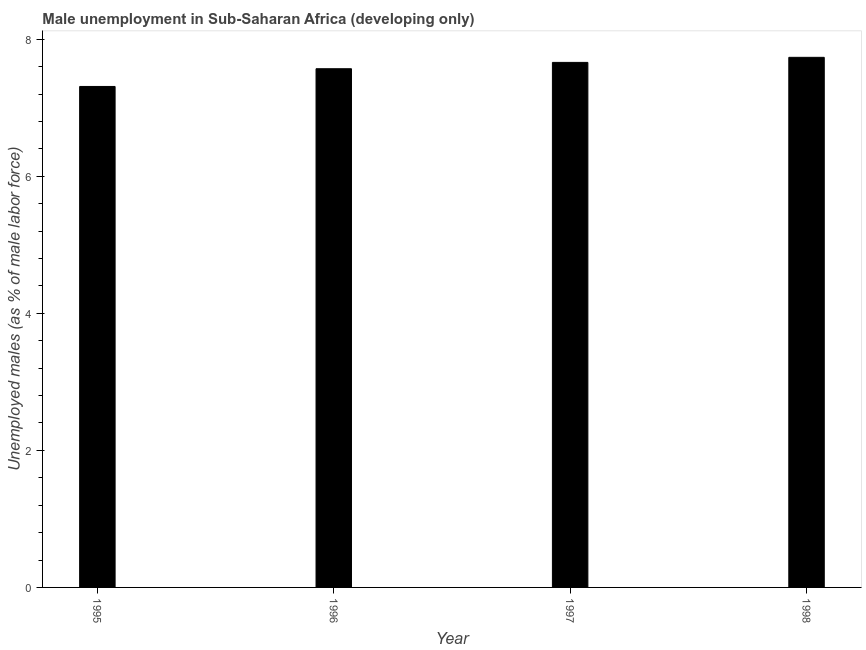What is the title of the graph?
Your answer should be compact. Male unemployment in Sub-Saharan Africa (developing only). What is the label or title of the Y-axis?
Offer a very short reply. Unemployed males (as % of male labor force). What is the unemployed males population in 1998?
Provide a succinct answer. 7.74. Across all years, what is the maximum unemployed males population?
Offer a terse response. 7.74. Across all years, what is the minimum unemployed males population?
Ensure brevity in your answer.  7.31. In which year was the unemployed males population maximum?
Keep it short and to the point. 1998. In which year was the unemployed males population minimum?
Offer a terse response. 1995. What is the sum of the unemployed males population?
Give a very brief answer. 30.28. What is the difference between the unemployed males population in 1995 and 1996?
Your response must be concise. -0.26. What is the average unemployed males population per year?
Provide a succinct answer. 7.57. What is the median unemployed males population?
Provide a succinct answer. 7.61. In how many years, is the unemployed males population greater than 7.2 %?
Offer a terse response. 4. Do a majority of the years between 1995 and 1996 (inclusive) have unemployed males population greater than 6 %?
Offer a very short reply. Yes. What is the ratio of the unemployed males population in 1996 to that in 1997?
Your response must be concise. 0.99. Is the unemployed males population in 1995 less than that in 1996?
Your response must be concise. Yes. Is the difference between the unemployed males population in 1995 and 1996 greater than the difference between any two years?
Offer a terse response. No. What is the difference between the highest and the second highest unemployed males population?
Make the answer very short. 0.07. What is the difference between the highest and the lowest unemployed males population?
Give a very brief answer. 0.43. How many bars are there?
Your answer should be compact. 4. Are all the bars in the graph horizontal?
Offer a terse response. No. What is the difference between two consecutive major ticks on the Y-axis?
Make the answer very short. 2. What is the Unemployed males (as % of male labor force) in 1995?
Your answer should be compact. 7.31. What is the Unemployed males (as % of male labor force) of 1996?
Make the answer very short. 7.57. What is the Unemployed males (as % of male labor force) in 1997?
Offer a very short reply. 7.66. What is the Unemployed males (as % of male labor force) in 1998?
Keep it short and to the point. 7.74. What is the difference between the Unemployed males (as % of male labor force) in 1995 and 1996?
Offer a terse response. -0.26. What is the difference between the Unemployed males (as % of male labor force) in 1995 and 1997?
Provide a short and direct response. -0.35. What is the difference between the Unemployed males (as % of male labor force) in 1995 and 1998?
Give a very brief answer. -0.43. What is the difference between the Unemployed males (as % of male labor force) in 1996 and 1997?
Ensure brevity in your answer.  -0.09. What is the difference between the Unemployed males (as % of male labor force) in 1996 and 1998?
Your answer should be very brief. -0.17. What is the difference between the Unemployed males (as % of male labor force) in 1997 and 1998?
Give a very brief answer. -0.07. What is the ratio of the Unemployed males (as % of male labor force) in 1995 to that in 1996?
Provide a succinct answer. 0.97. What is the ratio of the Unemployed males (as % of male labor force) in 1995 to that in 1997?
Provide a succinct answer. 0.95. What is the ratio of the Unemployed males (as % of male labor force) in 1995 to that in 1998?
Your response must be concise. 0.94. What is the ratio of the Unemployed males (as % of male labor force) in 1997 to that in 1998?
Offer a very short reply. 0.99. 